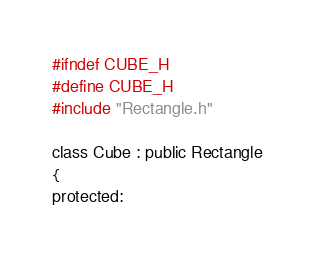Convert code to text. <code><loc_0><loc_0><loc_500><loc_500><_C_>#ifndef CUBE_H
#define CUBE_H
#include "Rectangle.h"

class Cube : public Rectangle
{
protected:</code> 